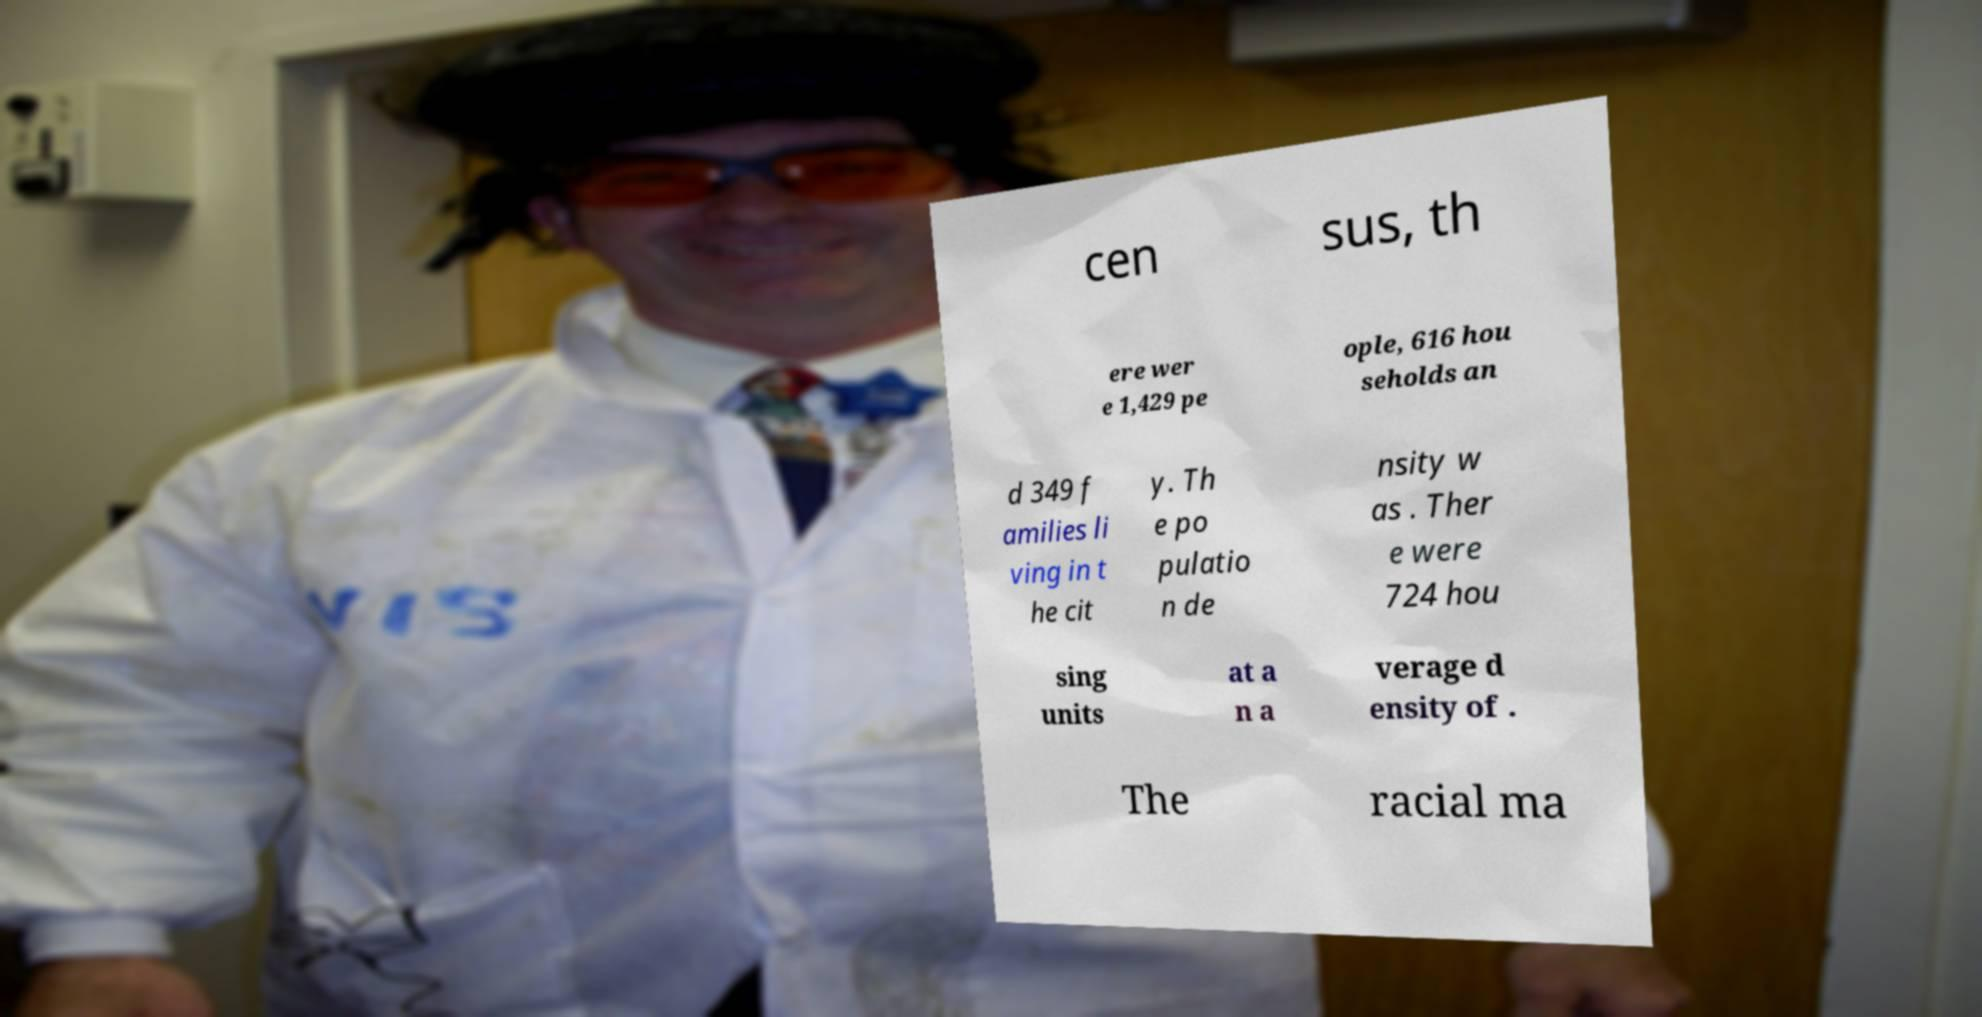What messages or text are displayed in this image? I need them in a readable, typed format. cen sus, th ere wer e 1,429 pe ople, 616 hou seholds an d 349 f amilies li ving in t he cit y. Th e po pulatio n de nsity w as . Ther e were 724 hou sing units at a n a verage d ensity of . The racial ma 